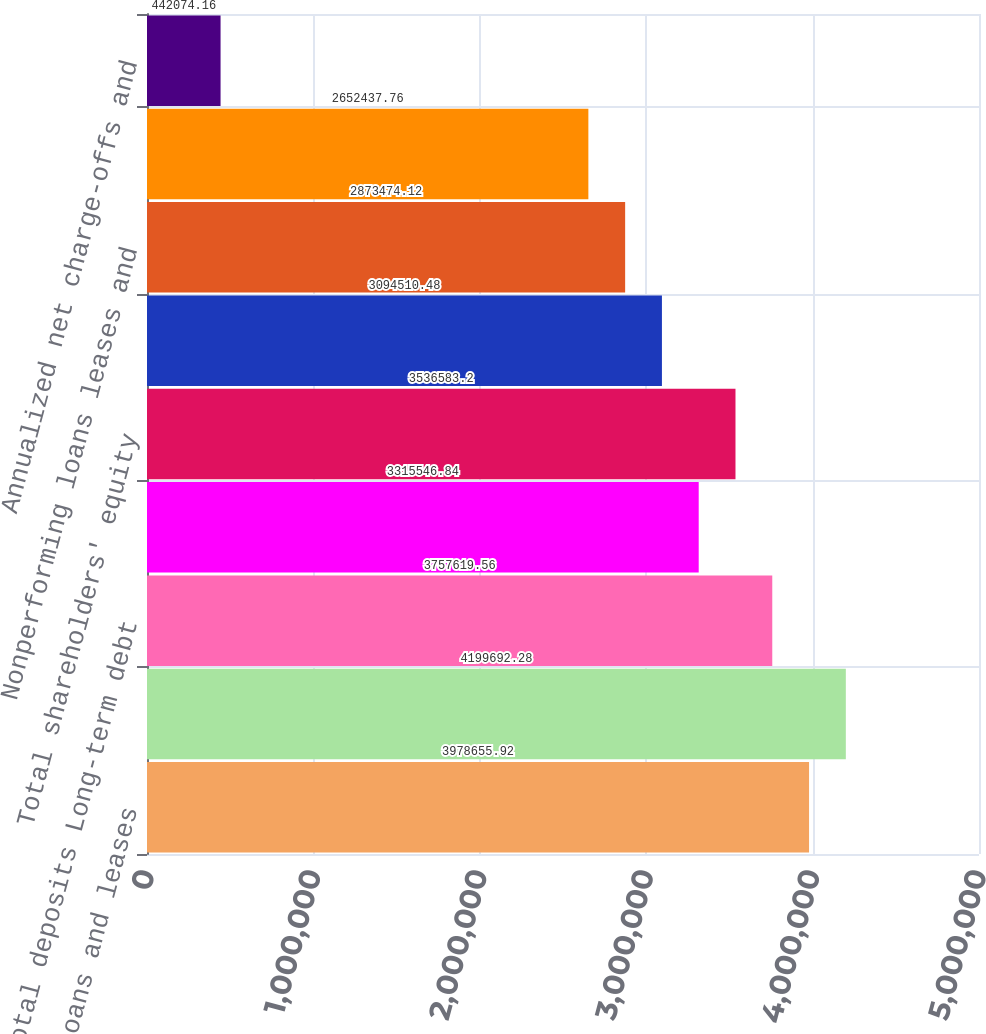<chart> <loc_0><loc_0><loc_500><loc_500><bar_chart><fcel>Total loans and leases<fcel>Total assets<fcel>Total deposits Long-term debt<fcel>Common shareholders' equity<fcel>Total shareholders' equity<fcel>Allowance for credit losses<fcel>Nonperforming loans leases and<fcel>Allowance for loan and lease<fcel>Annualized net charge-offs and<nl><fcel>3.97866e+06<fcel>4.19969e+06<fcel>3.75762e+06<fcel>3.31555e+06<fcel>3.53658e+06<fcel>3.09451e+06<fcel>2.87347e+06<fcel>2.65244e+06<fcel>442074<nl></chart> 